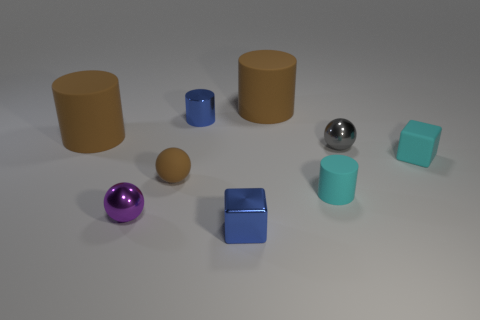Add 1 metallic cubes. How many objects exist? 10 Subtract all blocks. How many objects are left? 7 Subtract 1 brown cylinders. How many objects are left? 8 Subtract all purple metallic spheres. Subtract all large green matte cubes. How many objects are left? 8 Add 1 small metal cylinders. How many small metal cylinders are left? 2 Add 7 purple spheres. How many purple spheres exist? 8 